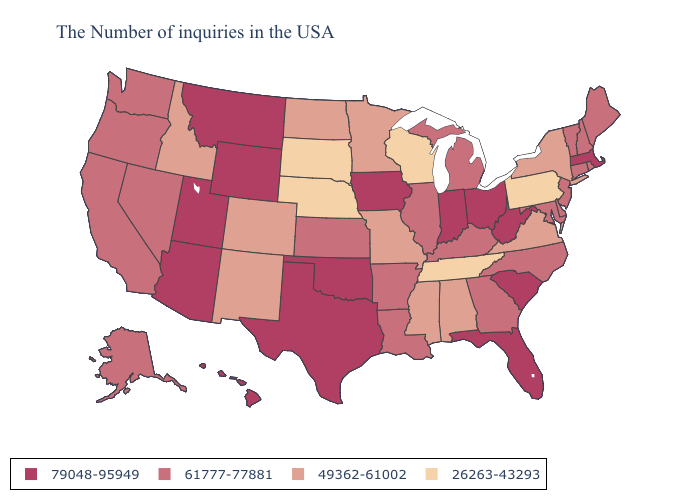Is the legend a continuous bar?
Write a very short answer. No. What is the lowest value in the USA?
Short answer required. 26263-43293. What is the highest value in states that border Arizona?
Short answer required. 79048-95949. Among the states that border New Hampshire , does Massachusetts have the highest value?
Write a very short answer. Yes. What is the value of Iowa?
Quick response, please. 79048-95949. Name the states that have a value in the range 49362-61002?
Quick response, please. New York, Virginia, Alabama, Mississippi, Missouri, Minnesota, North Dakota, Colorado, New Mexico, Idaho. Which states have the highest value in the USA?
Answer briefly. Massachusetts, South Carolina, West Virginia, Ohio, Florida, Indiana, Iowa, Oklahoma, Texas, Wyoming, Utah, Montana, Arizona, Hawaii. Name the states that have a value in the range 26263-43293?
Give a very brief answer. Pennsylvania, Tennessee, Wisconsin, Nebraska, South Dakota. What is the value of Maryland?
Be succinct. 61777-77881. Does the map have missing data?
Write a very short answer. No. Does Connecticut have a lower value than Hawaii?
Keep it brief. Yes. Does Idaho have a lower value than Arkansas?
Be succinct. Yes. Name the states that have a value in the range 49362-61002?
Quick response, please. New York, Virginia, Alabama, Mississippi, Missouri, Minnesota, North Dakota, Colorado, New Mexico, Idaho. What is the value of Washington?
Quick response, please. 61777-77881. 